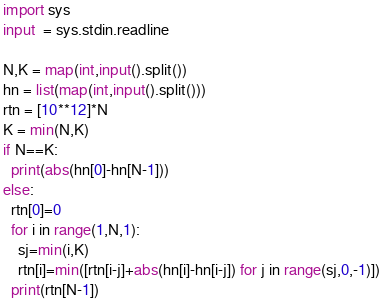<code> <loc_0><loc_0><loc_500><loc_500><_Python_>import sys
input  = sys.stdin.readline
 
N,K = map(int,input().split())
hn = list(map(int,input().split()))
rtn = [10**12]*N
K = min(N,K)
if N==K:
  print(abs(hn[0]-hn[N-1]))
else:
  rtn[0]=0
  for i in range(1,N,1):
    sj=min(i,K)
    rtn[i]=min([rtn[i-j]+abs(hn[i]-hn[i-j]) for j in range(sj,0,-1)])
  print(rtn[N-1])</code> 